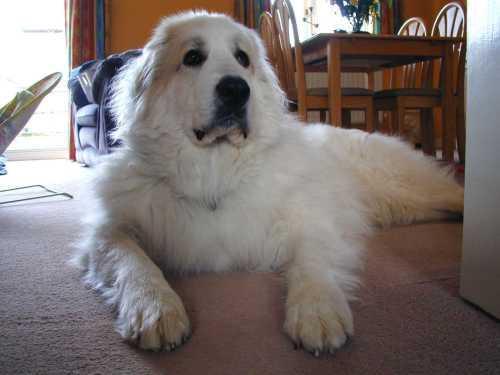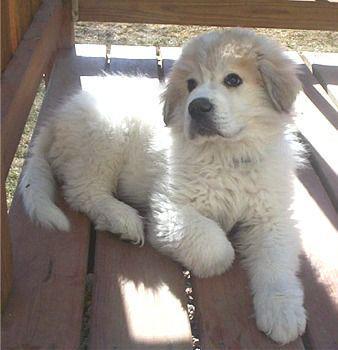The first image is the image on the left, the second image is the image on the right. Examine the images to the left and right. Is the description "One dog is sitting." accurate? Answer yes or no. No. The first image is the image on the left, the second image is the image on the right. Analyze the images presented: Is the assertion "there are two dogs in the image pair" valid? Answer yes or no. Yes. 